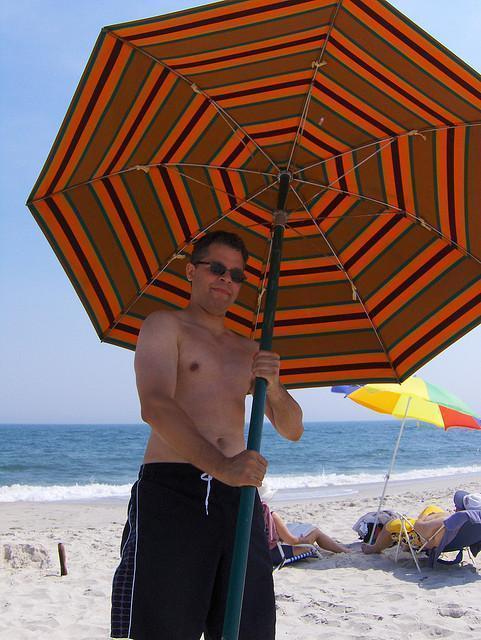If he is going to step out from under this structure he should put on what?
Select the correct answer and articulate reasoning with the following format: 'Answer: answer
Rationale: rationale.'
Options: Sunblock, shoes, suit, music. Answer: sunblock.
Rationale: The person needs sunscreen. 